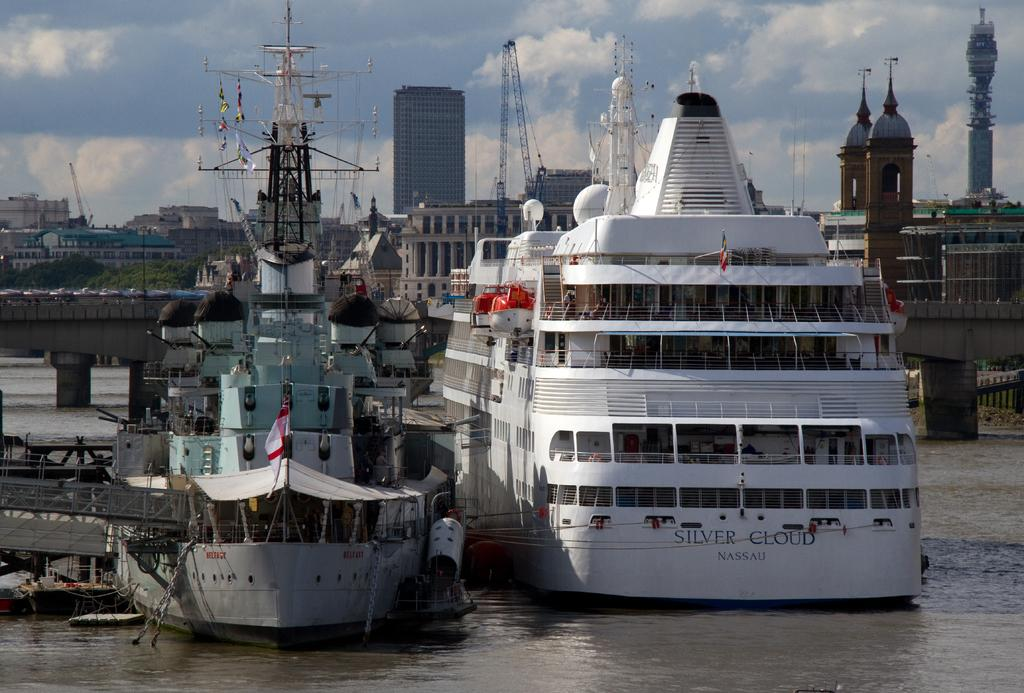<image>
Offer a succinct explanation of the picture presented. a silver cloud boat that is sitting in the water 